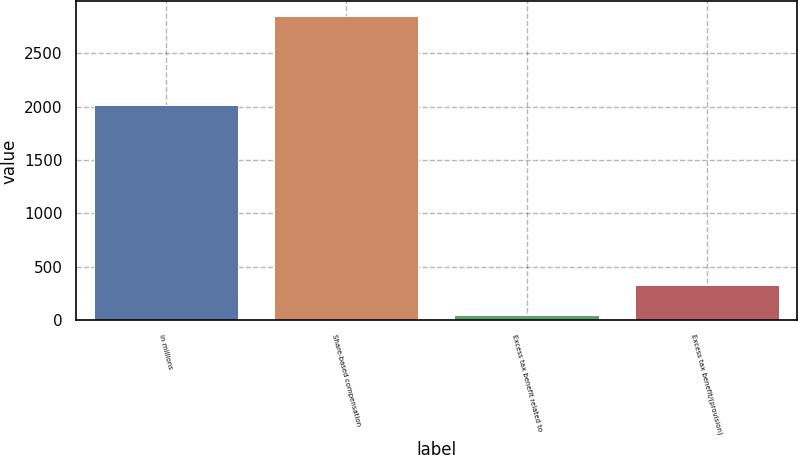<chart> <loc_0><loc_0><loc_500><loc_500><bar_chart><fcel>in millions<fcel>Share-based compensation<fcel>Excess tax benefit related to<fcel>Excess tax benefit/(provision)<nl><fcel>2011<fcel>2843<fcel>55<fcel>333.8<nl></chart> 